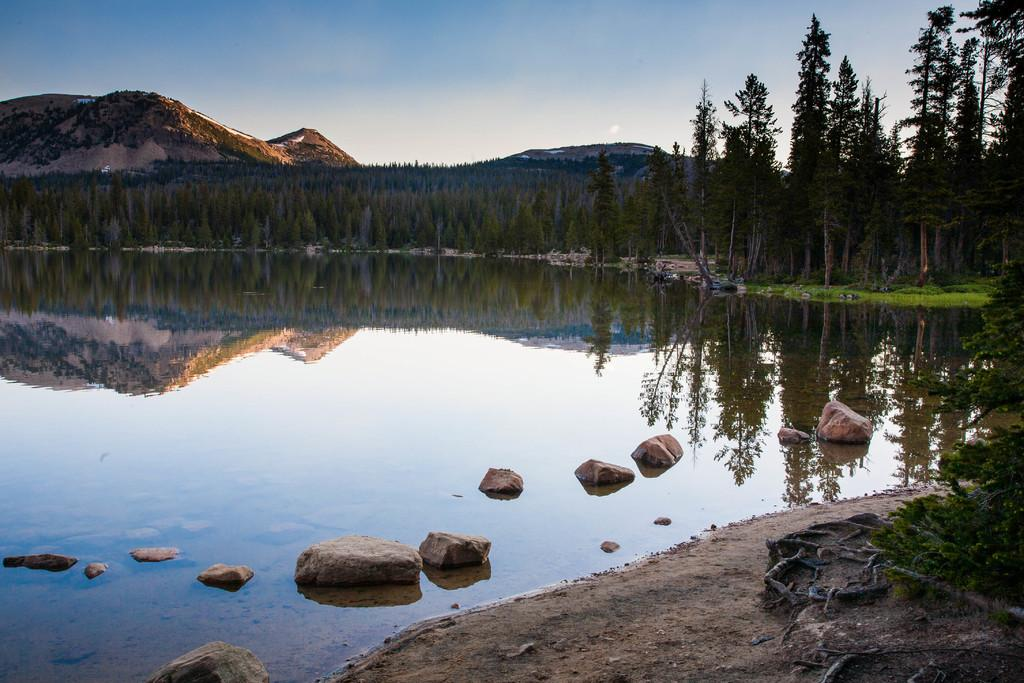What can be seen in the foreground of the image? In the foreground of the image, there is water and stones. What is visible in the background of the image? In the background of the image, there are trees, mountains, and the sky. Can you describe the texture of the image? The image has a muddy texture. What type of vegetation is present at the bottom side of the image? There is greenery at the bottom side of the image. What type of science experiment is being conducted in the image? There is no science experiment present in the image. Where is the home located in the image? There is no home present in the image. 